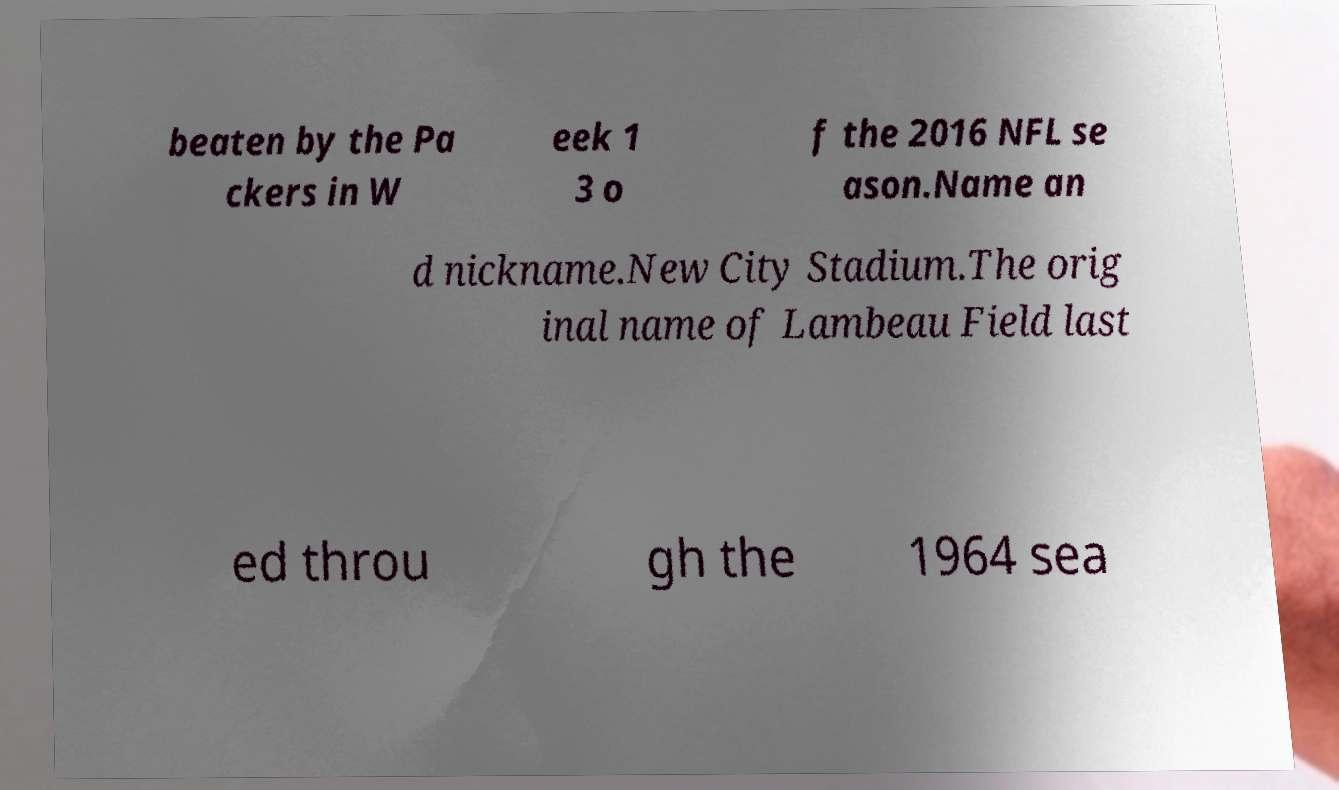There's text embedded in this image that I need extracted. Can you transcribe it verbatim? beaten by the Pa ckers in W eek 1 3 o f the 2016 NFL se ason.Name an d nickname.New City Stadium.The orig inal name of Lambeau Field last ed throu gh the 1964 sea 